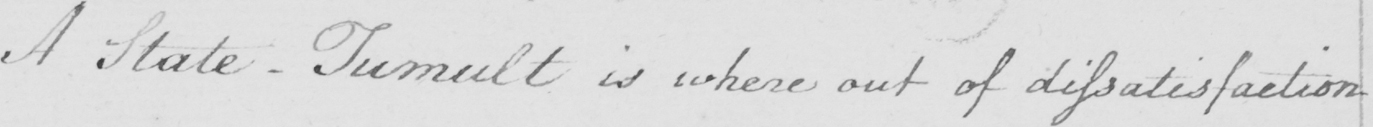Please transcribe the handwritten text in this image. A State-Tumult is where out of dissatisfaction 